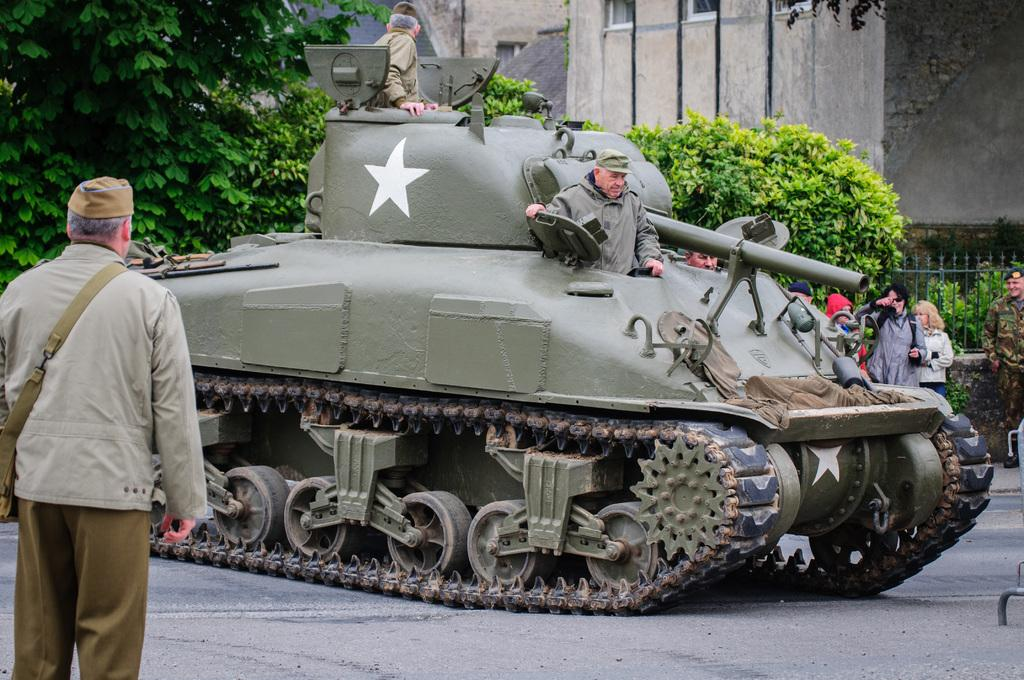What is the main subject of the image? There is a man standing in the image. What else can be seen in the image besides the man? There are people in a tank, a road, and people and objects in the background of the image. Can you describe the background of the image? In the background, there is a fence, trees, and a wall visible. What is the effect of the spring on the vein in the image? There is no spring or vein present in the image. 